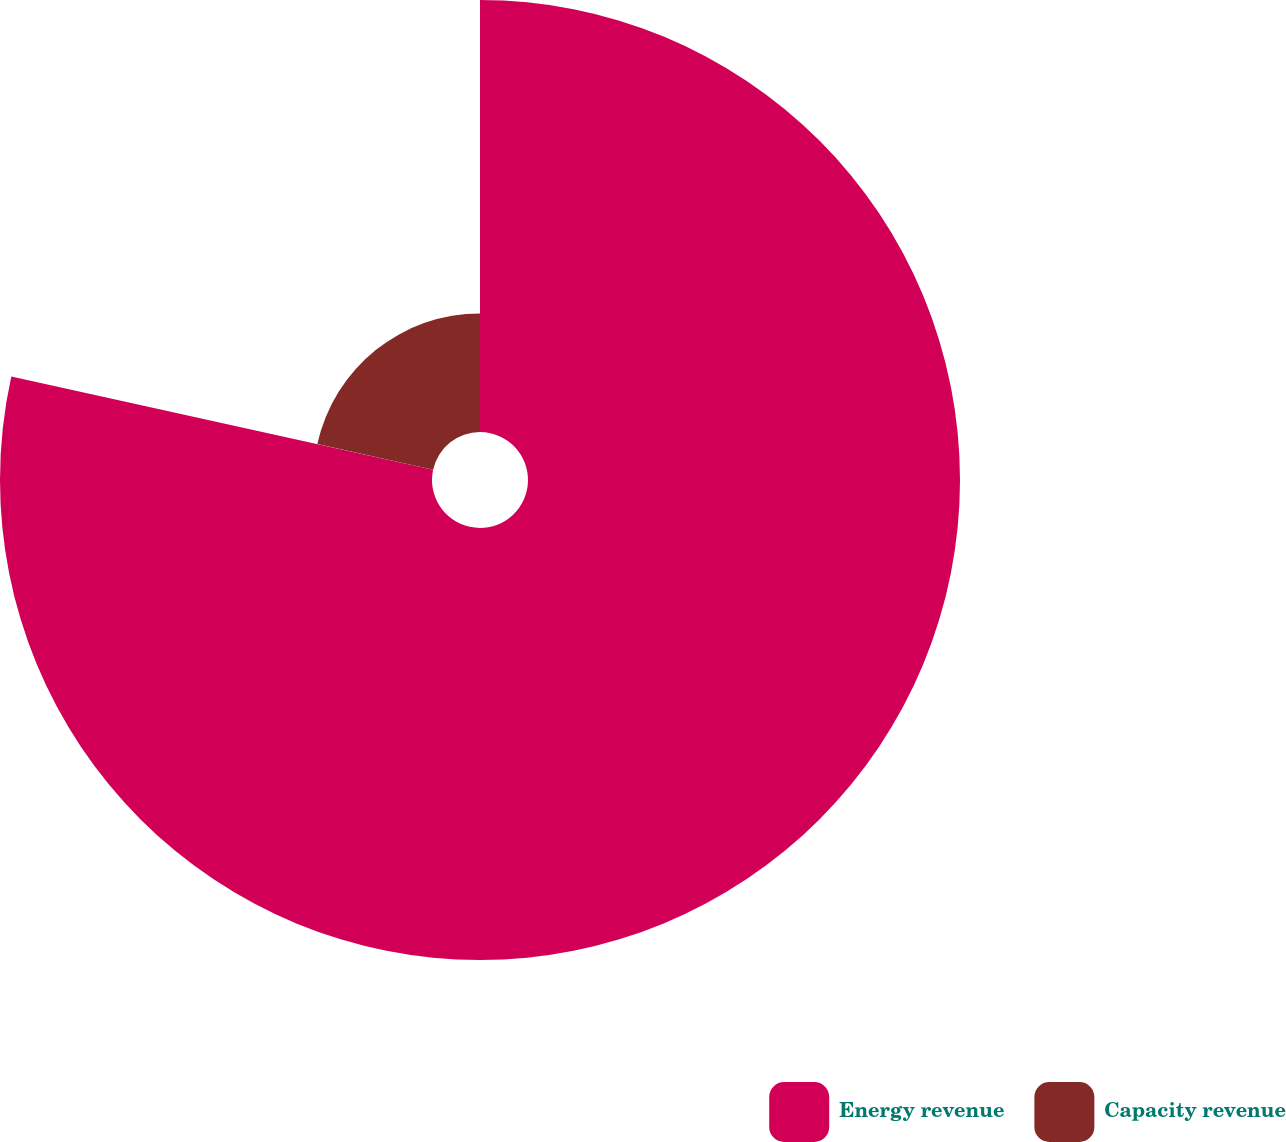<chart> <loc_0><loc_0><loc_500><loc_500><pie_chart><fcel>Energy revenue<fcel>Capacity revenue<nl><fcel>78.46%<fcel>21.54%<nl></chart> 